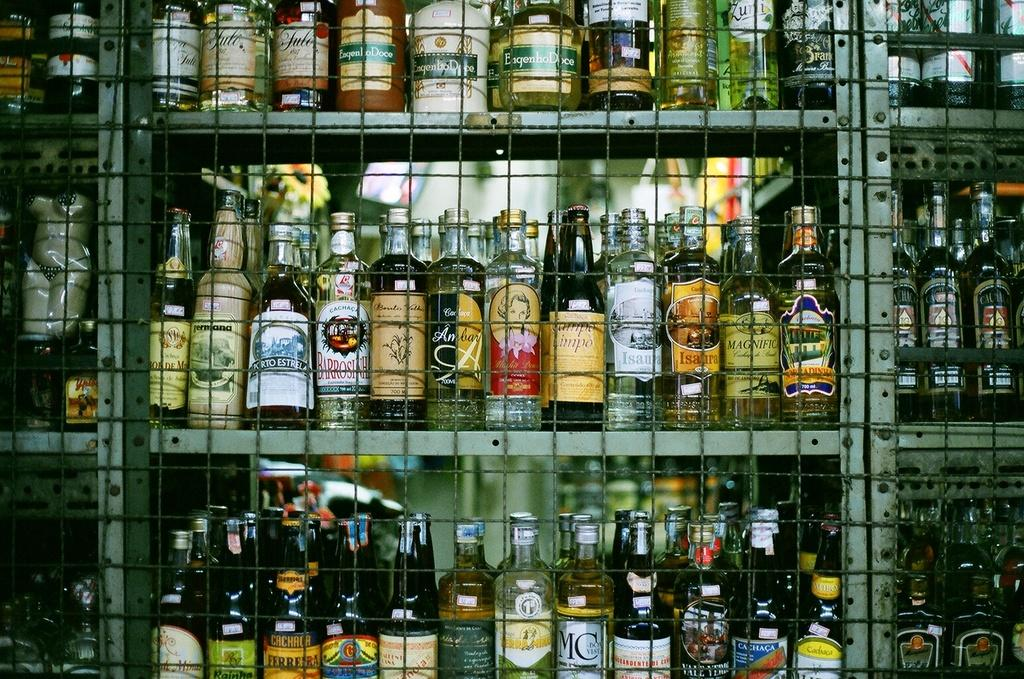<image>
Describe the image concisely. Rows of liquor like Cachaca on shelves in a store. 